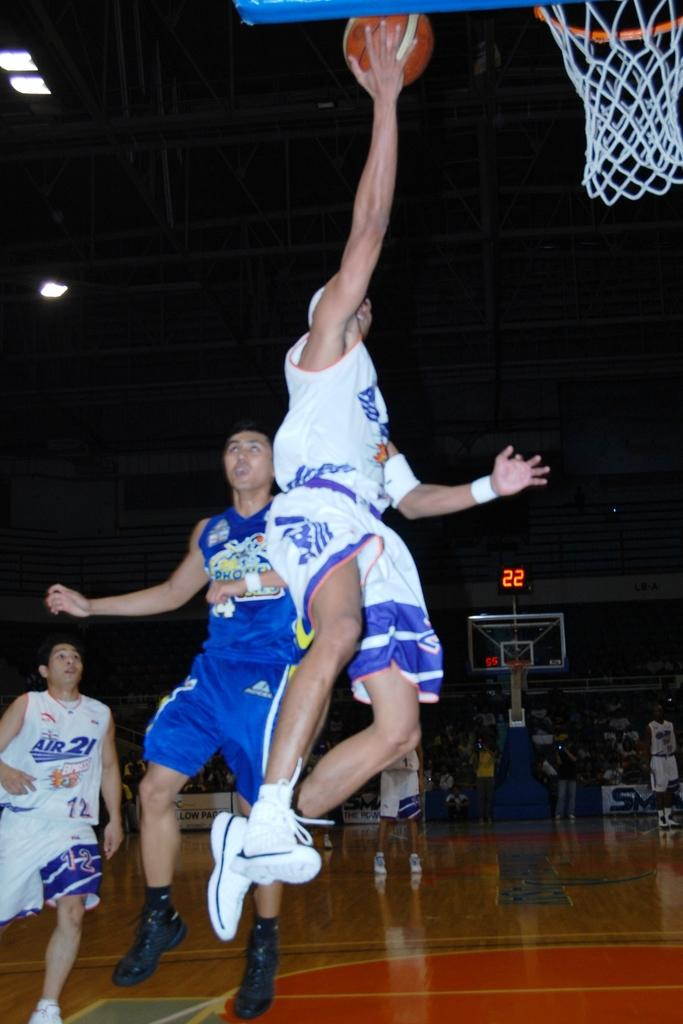<image>
Create a compact narrative representing the image presented. A basketball game is gong on with one of the players having an AIR 21 EXPRESS uniform on and # 12. 